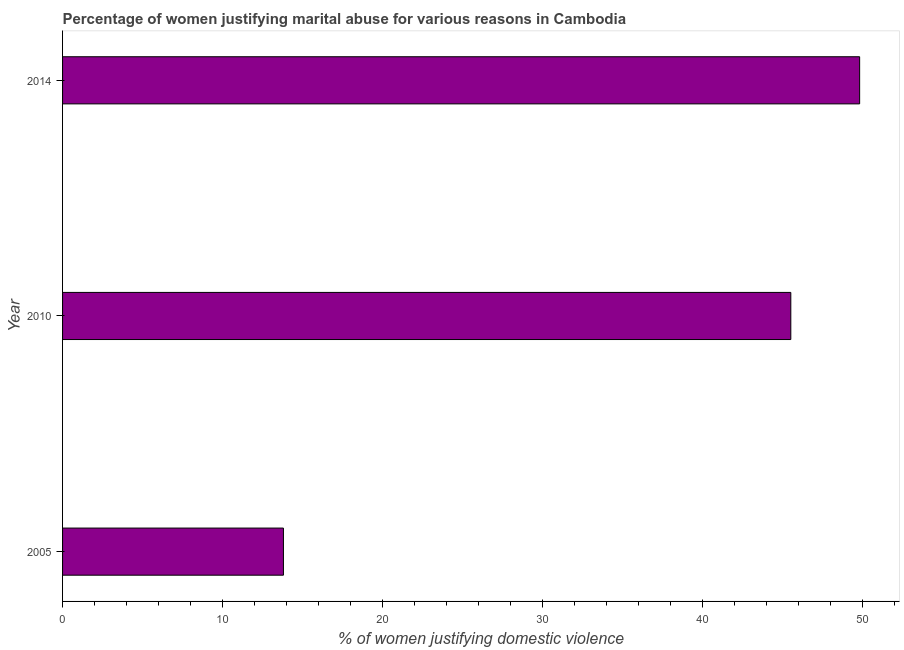What is the title of the graph?
Your answer should be compact. Percentage of women justifying marital abuse for various reasons in Cambodia. What is the label or title of the X-axis?
Your answer should be very brief. % of women justifying domestic violence. What is the label or title of the Y-axis?
Provide a short and direct response. Year. What is the percentage of women justifying marital abuse in 2005?
Offer a very short reply. 13.8. Across all years, what is the maximum percentage of women justifying marital abuse?
Make the answer very short. 49.8. What is the sum of the percentage of women justifying marital abuse?
Make the answer very short. 109.1. What is the difference between the percentage of women justifying marital abuse in 2005 and 2010?
Provide a short and direct response. -31.7. What is the average percentage of women justifying marital abuse per year?
Your answer should be compact. 36.37. What is the median percentage of women justifying marital abuse?
Make the answer very short. 45.5. In how many years, is the percentage of women justifying marital abuse greater than 8 %?
Provide a short and direct response. 3. What is the ratio of the percentage of women justifying marital abuse in 2005 to that in 2014?
Your answer should be very brief. 0.28. Is the percentage of women justifying marital abuse in 2010 less than that in 2014?
Your answer should be very brief. Yes. Is the difference between the percentage of women justifying marital abuse in 2010 and 2014 greater than the difference between any two years?
Your answer should be very brief. No. What is the difference between the highest and the second highest percentage of women justifying marital abuse?
Your response must be concise. 4.3. In how many years, is the percentage of women justifying marital abuse greater than the average percentage of women justifying marital abuse taken over all years?
Your answer should be compact. 2. What is the % of women justifying domestic violence of 2010?
Offer a very short reply. 45.5. What is the % of women justifying domestic violence of 2014?
Offer a very short reply. 49.8. What is the difference between the % of women justifying domestic violence in 2005 and 2010?
Keep it short and to the point. -31.7. What is the difference between the % of women justifying domestic violence in 2005 and 2014?
Provide a succinct answer. -36. What is the ratio of the % of women justifying domestic violence in 2005 to that in 2010?
Provide a succinct answer. 0.3. What is the ratio of the % of women justifying domestic violence in 2005 to that in 2014?
Offer a terse response. 0.28. What is the ratio of the % of women justifying domestic violence in 2010 to that in 2014?
Provide a short and direct response. 0.91. 